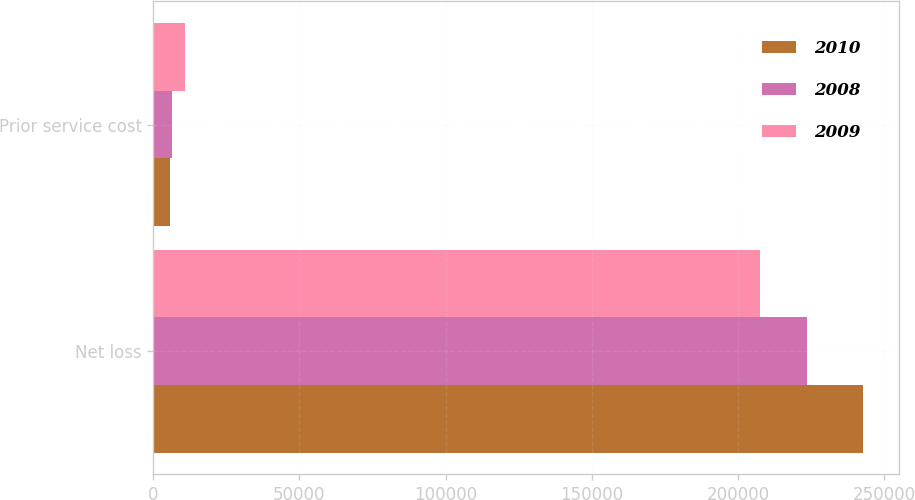<chart> <loc_0><loc_0><loc_500><loc_500><stacked_bar_chart><ecel><fcel>Net loss<fcel>Prior service cost<nl><fcel>2010<fcel>242902<fcel>5578<nl><fcel>2008<fcel>223497<fcel>6548<nl><fcel>2009<fcel>207391<fcel>10705<nl></chart> 